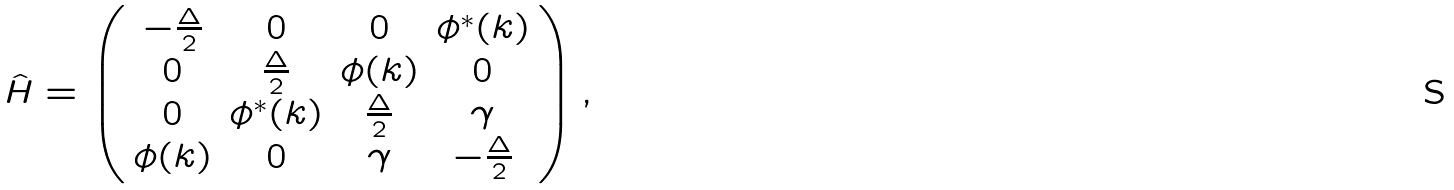<formula> <loc_0><loc_0><loc_500><loc_500>\hat { H } = \left ( \begin{array} { c c c c } - \frac { \Delta } { 2 } & 0 & 0 & \phi ^ { * } ( { k } ) \\ 0 & \frac { \Delta } { 2 } & \phi ( { k } ) & 0 \\ 0 & \phi ^ { * } ( { k } ) & \frac { \Delta } { 2 } & \gamma \\ \phi ( { k } ) & 0 & \gamma & - \frac { \Delta } { 2 } \end{array} \right ) ,</formula> 